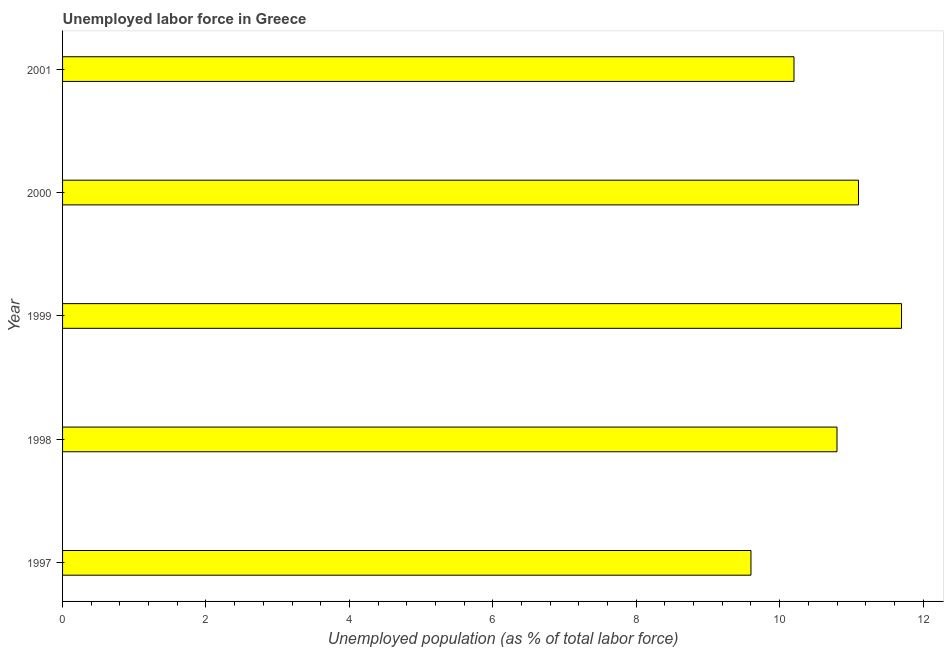Does the graph contain any zero values?
Provide a short and direct response. No. Does the graph contain grids?
Make the answer very short. No. What is the title of the graph?
Your answer should be very brief. Unemployed labor force in Greece. What is the label or title of the X-axis?
Your answer should be compact. Unemployed population (as % of total labor force). What is the total unemployed population in 2001?
Ensure brevity in your answer.  10.2. Across all years, what is the maximum total unemployed population?
Your response must be concise. 11.7. Across all years, what is the minimum total unemployed population?
Offer a very short reply. 9.6. In which year was the total unemployed population maximum?
Ensure brevity in your answer.  1999. What is the sum of the total unemployed population?
Provide a succinct answer. 53.4. What is the average total unemployed population per year?
Offer a terse response. 10.68. What is the median total unemployed population?
Offer a terse response. 10.8. Do a majority of the years between 1998 and 2000 (inclusive) have total unemployed population greater than 1.6 %?
Ensure brevity in your answer.  Yes. What is the ratio of the total unemployed population in 1998 to that in 2000?
Give a very brief answer. 0.97. What is the difference between the highest and the second highest total unemployed population?
Make the answer very short. 0.6. Is the sum of the total unemployed population in 1998 and 1999 greater than the maximum total unemployed population across all years?
Give a very brief answer. Yes. What is the difference between the highest and the lowest total unemployed population?
Provide a short and direct response. 2.1. How many bars are there?
Provide a short and direct response. 5. Are all the bars in the graph horizontal?
Your response must be concise. Yes. What is the difference between two consecutive major ticks on the X-axis?
Your response must be concise. 2. What is the Unemployed population (as % of total labor force) in 1997?
Ensure brevity in your answer.  9.6. What is the Unemployed population (as % of total labor force) of 1998?
Your response must be concise. 10.8. What is the Unemployed population (as % of total labor force) in 1999?
Your answer should be compact. 11.7. What is the Unemployed population (as % of total labor force) in 2000?
Provide a short and direct response. 11.1. What is the Unemployed population (as % of total labor force) in 2001?
Ensure brevity in your answer.  10.2. What is the difference between the Unemployed population (as % of total labor force) in 1997 and 1999?
Keep it short and to the point. -2.1. What is the difference between the Unemployed population (as % of total labor force) in 1998 and 1999?
Provide a succinct answer. -0.9. What is the difference between the Unemployed population (as % of total labor force) in 1998 and 2001?
Your answer should be very brief. 0.6. What is the difference between the Unemployed population (as % of total labor force) in 2000 and 2001?
Your answer should be very brief. 0.9. What is the ratio of the Unemployed population (as % of total labor force) in 1997 to that in 1998?
Give a very brief answer. 0.89. What is the ratio of the Unemployed population (as % of total labor force) in 1997 to that in 1999?
Ensure brevity in your answer.  0.82. What is the ratio of the Unemployed population (as % of total labor force) in 1997 to that in 2000?
Provide a short and direct response. 0.86. What is the ratio of the Unemployed population (as % of total labor force) in 1997 to that in 2001?
Your answer should be compact. 0.94. What is the ratio of the Unemployed population (as % of total labor force) in 1998 to that in 1999?
Ensure brevity in your answer.  0.92. What is the ratio of the Unemployed population (as % of total labor force) in 1998 to that in 2000?
Give a very brief answer. 0.97. What is the ratio of the Unemployed population (as % of total labor force) in 1998 to that in 2001?
Give a very brief answer. 1.06. What is the ratio of the Unemployed population (as % of total labor force) in 1999 to that in 2000?
Provide a succinct answer. 1.05. What is the ratio of the Unemployed population (as % of total labor force) in 1999 to that in 2001?
Your answer should be compact. 1.15. What is the ratio of the Unemployed population (as % of total labor force) in 2000 to that in 2001?
Give a very brief answer. 1.09. 